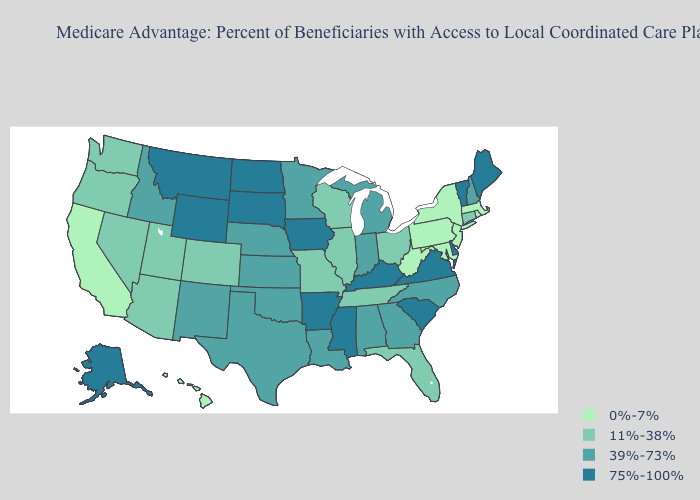Which states have the highest value in the USA?
Concise answer only. Alaska, Arkansas, Delaware, Iowa, Kentucky, Maine, Mississippi, Montana, North Dakota, South Carolina, South Dakota, Virginia, Vermont, Wyoming. Name the states that have a value in the range 39%-73%?
Short answer required. Alabama, Georgia, Idaho, Indiana, Kansas, Louisiana, Michigan, Minnesota, North Carolina, Nebraska, New Hampshire, New Mexico, Oklahoma, Texas. Among the states that border Oklahoma , does Missouri have the lowest value?
Be succinct. Yes. Name the states that have a value in the range 0%-7%?
Write a very short answer. California, Hawaii, Massachusetts, Maryland, New Jersey, New York, Pennsylvania, Rhode Island, West Virginia. Name the states that have a value in the range 0%-7%?
Be succinct. California, Hawaii, Massachusetts, Maryland, New Jersey, New York, Pennsylvania, Rhode Island, West Virginia. What is the highest value in the USA?
Be succinct. 75%-100%. Among the states that border Florida , which have the highest value?
Keep it brief. Alabama, Georgia. Name the states that have a value in the range 11%-38%?
Short answer required. Arizona, Colorado, Connecticut, Florida, Illinois, Missouri, Nevada, Ohio, Oregon, Tennessee, Utah, Washington, Wisconsin. What is the lowest value in the Northeast?
Quick response, please. 0%-7%. What is the value of South Carolina?
Quick response, please. 75%-100%. Name the states that have a value in the range 75%-100%?
Keep it brief. Alaska, Arkansas, Delaware, Iowa, Kentucky, Maine, Mississippi, Montana, North Dakota, South Carolina, South Dakota, Virginia, Vermont, Wyoming. Among the states that border Nevada , which have the lowest value?
Give a very brief answer. California. What is the value of Georgia?
Answer briefly. 39%-73%. Does Washington have the lowest value in the West?
Short answer required. No. What is the highest value in the Northeast ?
Short answer required. 75%-100%. 